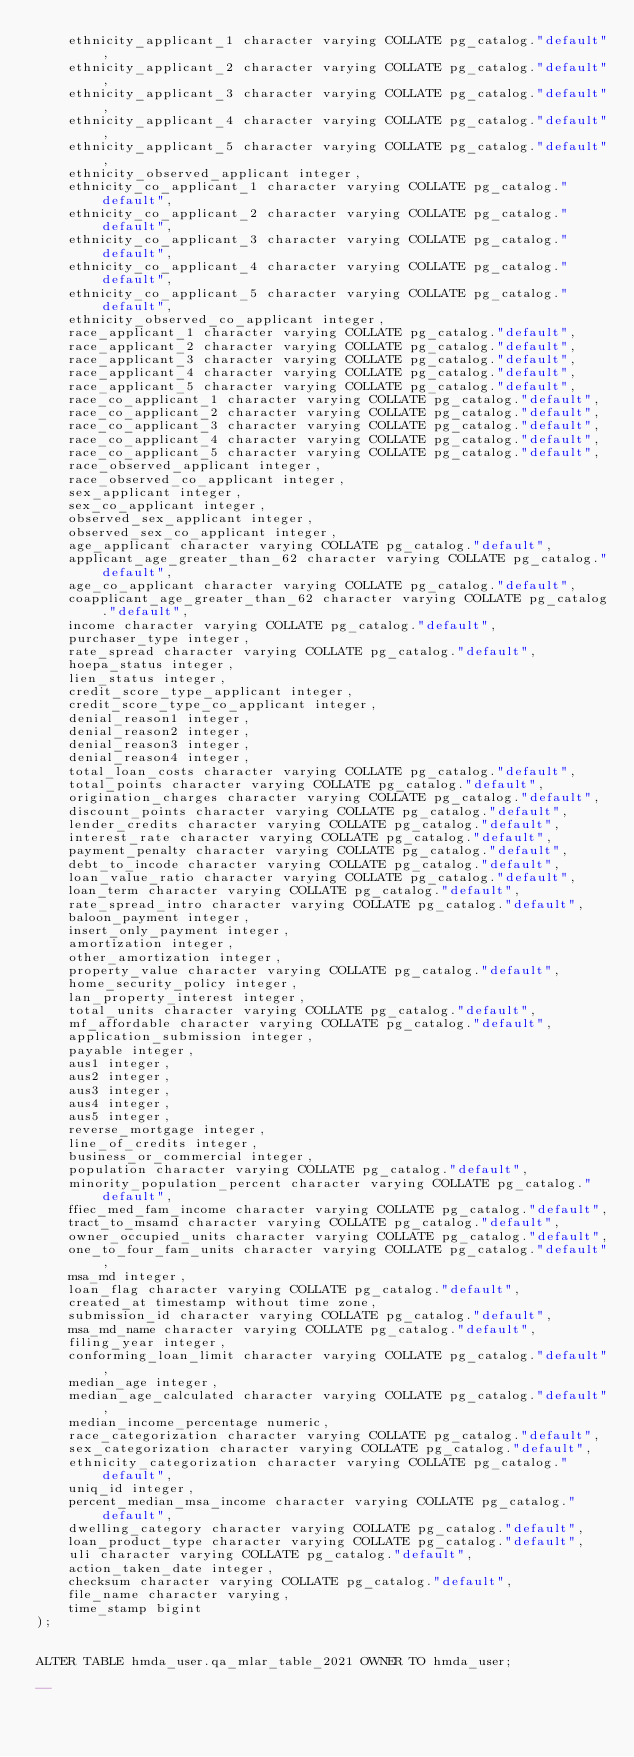<code> <loc_0><loc_0><loc_500><loc_500><_SQL_>    ethnicity_applicant_1 character varying COLLATE pg_catalog."default",
    ethnicity_applicant_2 character varying COLLATE pg_catalog."default",
    ethnicity_applicant_3 character varying COLLATE pg_catalog."default",
    ethnicity_applicant_4 character varying COLLATE pg_catalog."default",
    ethnicity_applicant_5 character varying COLLATE pg_catalog."default",
    ethnicity_observed_applicant integer,
    ethnicity_co_applicant_1 character varying COLLATE pg_catalog."default",
    ethnicity_co_applicant_2 character varying COLLATE pg_catalog."default",
    ethnicity_co_applicant_3 character varying COLLATE pg_catalog."default",
    ethnicity_co_applicant_4 character varying COLLATE pg_catalog."default",
    ethnicity_co_applicant_5 character varying COLLATE pg_catalog."default",
    ethnicity_observed_co_applicant integer,
    race_applicant_1 character varying COLLATE pg_catalog."default",
    race_applicant_2 character varying COLLATE pg_catalog."default",
    race_applicant_3 character varying COLLATE pg_catalog."default",
    race_applicant_4 character varying COLLATE pg_catalog."default",
    race_applicant_5 character varying COLLATE pg_catalog."default",
    race_co_applicant_1 character varying COLLATE pg_catalog."default",
    race_co_applicant_2 character varying COLLATE pg_catalog."default",
    race_co_applicant_3 character varying COLLATE pg_catalog."default",
    race_co_applicant_4 character varying COLLATE pg_catalog."default",
    race_co_applicant_5 character varying COLLATE pg_catalog."default",
    race_observed_applicant integer,
    race_observed_co_applicant integer,
    sex_applicant integer,
    sex_co_applicant integer,
    observed_sex_applicant integer,
    observed_sex_co_applicant integer,
    age_applicant character varying COLLATE pg_catalog."default",
    applicant_age_greater_than_62 character varying COLLATE pg_catalog."default",
    age_co_applicant character varying COLLATE pg_catalog."default",
    coapplicant_age_greater_than_62 character varying COLLATE pg_catalog."default",
    income character varying COLLATE pg_catalog."default",
    purchaser_type integer,
    rate_spread character varying COLLATE pg_catalog."default",
    hoepa_status integer,
    lien_status integer,
    credit_score_type_applicant integer,
    credit_score_type_co_applicant integer,
    denial_reason1 integer,
    denial_reason2 integer,
    denial_reason3 integer,
    denial_reason4 integer,
    total_loan_costs character varying COLLATE pg_catalog."default",
    total_points character varying COLLATE pg_catalog."default",
    origination_charges character varying COLLATE pg_catalog."default",
    discount_points character varying COLLATE pg_catalog."default",
    lender_credits character varying COLLATE pg_catalog."default",
    interest_rate character varying COLLATE pg_catalog."default",
    payment_penalty character varying COLLATE pg_catalog."default",
    debt_to_incode character varying COLLATE pg_catalog."default",
    loan_value_ratio character varying COLLATE pg_catalog."default",
    loan_term character varying COLLATE pg_catalog."default",
    rate_spread_intro character varying COLLATE pg_catalog."default",
    baloon_payment integer,
    insert_only_payment integer,
    amortization integer,
    other_amortization integer,
    property_value character varying COLLATE pg_catalog."default",
    home_security_policy integer,
    lan_property_interest integer,
    total_units character varying COLLATE pg_catalog."default",
    mf_affordable character varying COLLATE pg_catalog."default",
    application_submission integer,
    payable integer,
    aus1 integer,
    aus2 integer,
    aus3 integer,
    aus4 integer,
    aus5 integer,
    reverse_mortgage integer,
    line_of_credits integer,
    business_or_commercial integer,
    population character varying COLLATE pg_catalog."default",
    minority_population_percent character varying COLLATE pg_catalog."default",
    ffiec_med_fam_income character varying COLLATE pg_catalog."default",
    tract_to_msamd character varying COLLATE pg_catalog."default",
    owner_occupied_units character varying COLLATE pg_catalog."default",
    one_to_four_fam_units character varying COLLATE pg_catalog."default",
    msa_md integer,
    loan_flag character varying COLLATE pg_catalog."default",
    created_at timestamp without time zone,
    submission_id character varying COLLATE pg_catalog."default",
    msa_md_name character varying COLLATE pg_catalog."default",
    filing_year integer,
    conforming_loan_limit character varying COLLATE pg_catalog."default",
    median_age integer,
    median_age_calculated character varying COLLATE pg_catalog."default",
    median_income_percentage numeric,
    race_categorization character varying COLLATE pg_catalog."default",
    sex_categorization character varying COLLATE pg_catalog."default",
    ethnicity_categorization character varying COLLATE pg_catalog."default",
    uniq_id integer,
    percent_median_msa_income character varying COLLATE pg_catalog."default",
    dwelling_category character varying COLLATE pg_catalog."default",
    loan_product_type character varying COLLATE pg_catalog."default",
    uli character varying COLLATE pg_catalog."default",
    action_taken_date integer,
    checksum character varying COLLATE pg_catalog."default",
    file_name character varying,
    time_stamp bigint
);


ALTER TABLE hmda_user.qa_mlar_table_2021 OWNER TO hmda_user;

--</code> 